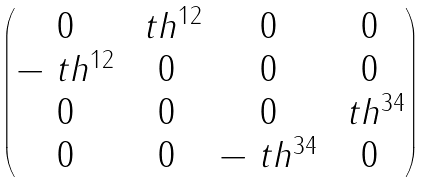<formula> <loc_0><loc_0><loc_500><loc_500>\begin{pmatrix} 0 & \ t h ^ { 1 2 } & 0 & 0 \\ - \ t h ^ { 1 2 } & 0 & 0 & 0 \\ 0 & 0 & 0 & \ t h ^ { 3 4 } \\ 0 & 0 & - \ t h ^ { 3 4 } & 0 \end{pmatrix}</formula> 